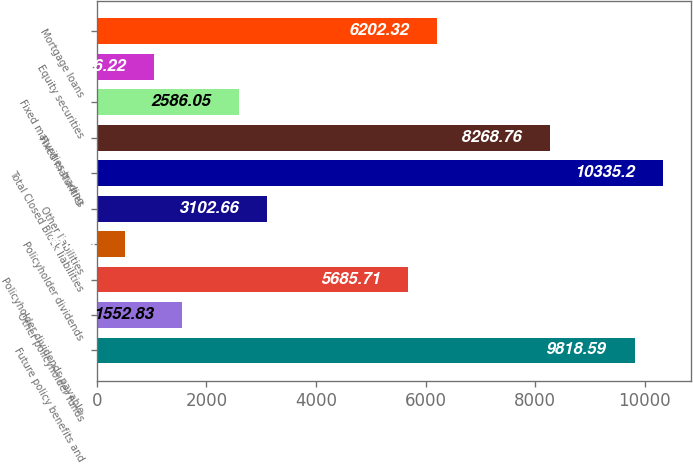Convert chart to OTSL. <chart><loc_0><loc_0><loc_500><loc_500><bar_chart><fcel>Future policy benefits and<fcel>Other policyholder funds<fcel>Policyholder dividends payable<fcel>Policyholder dividends<fcel>Other liabilities<fcel>Total Closed Block liabilities<fcel>Fixed maturities<fcel>Fixed maturities trading<fcel>Equity securities<fcel>Mortgage loans<nl><fcel>9818.59<fcel>1552.83<fcel>5685.71<fcel>519.61<fcel>3102.66<fcel>10335.2<fcel>8268.76<fcel>2586.05<fcel>1036.22<fcel>6202.32<nl></chart> 